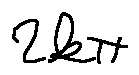<formula> <loc_0><loc_0><loc_500><loc_500>2 k \pi</formula> 